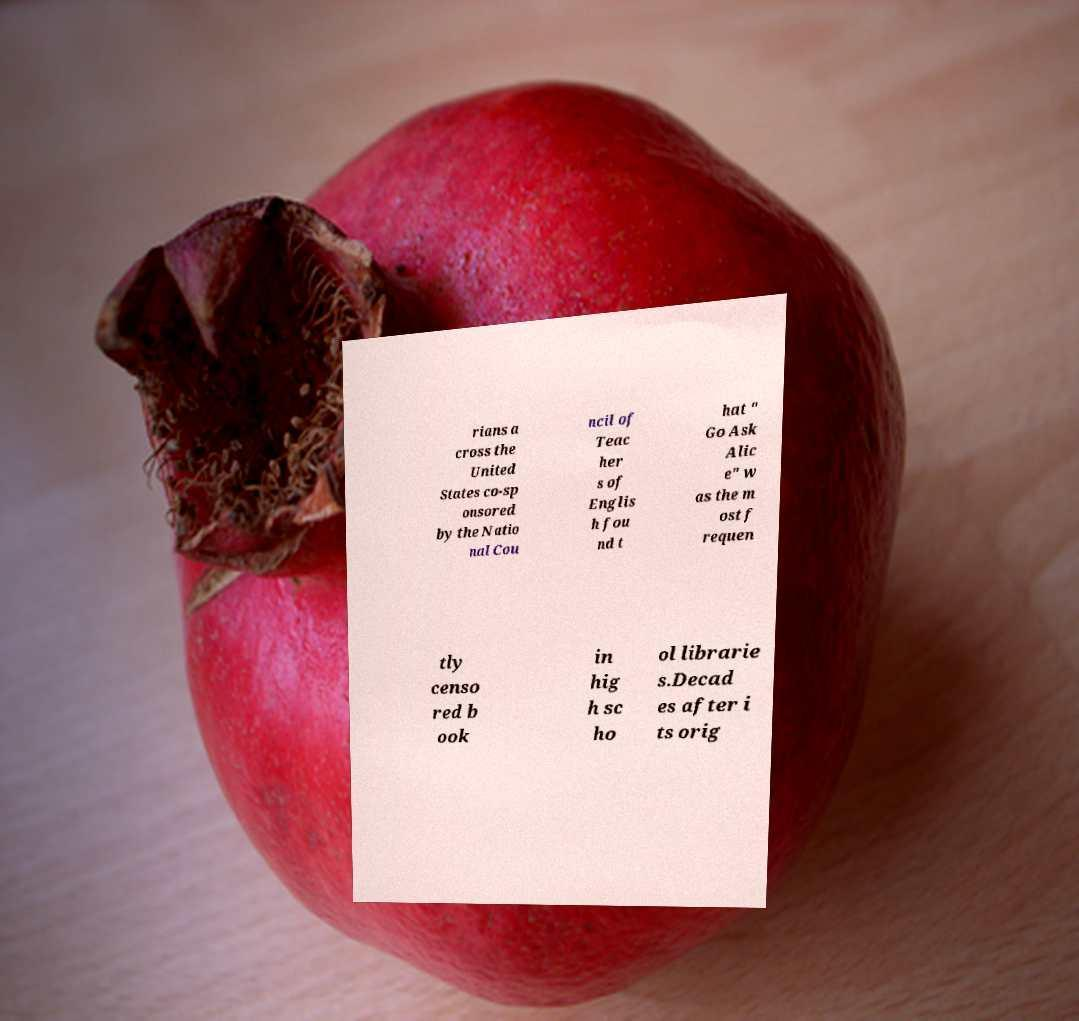Can you accurately transcribe the text from the provided image for me? rians a cross the United States co-sp onsored by the Natio nal Cou ncil of Teac her s of Englis h fou nd t hat " Go Ask Alic e" w as the m ost f requen tly censo red b ook in hig h sc ho ol librarie s.Decad es after i ts orig 